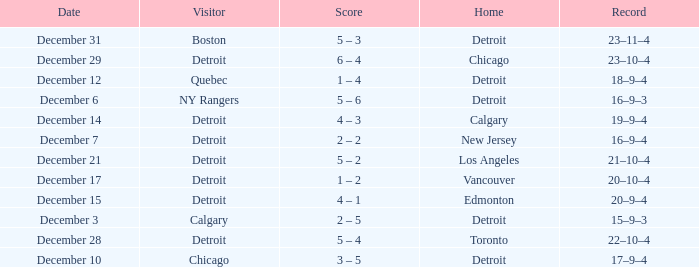What is the scheduled date for the home game in detroit with chicago as the visiting team? December 10. 